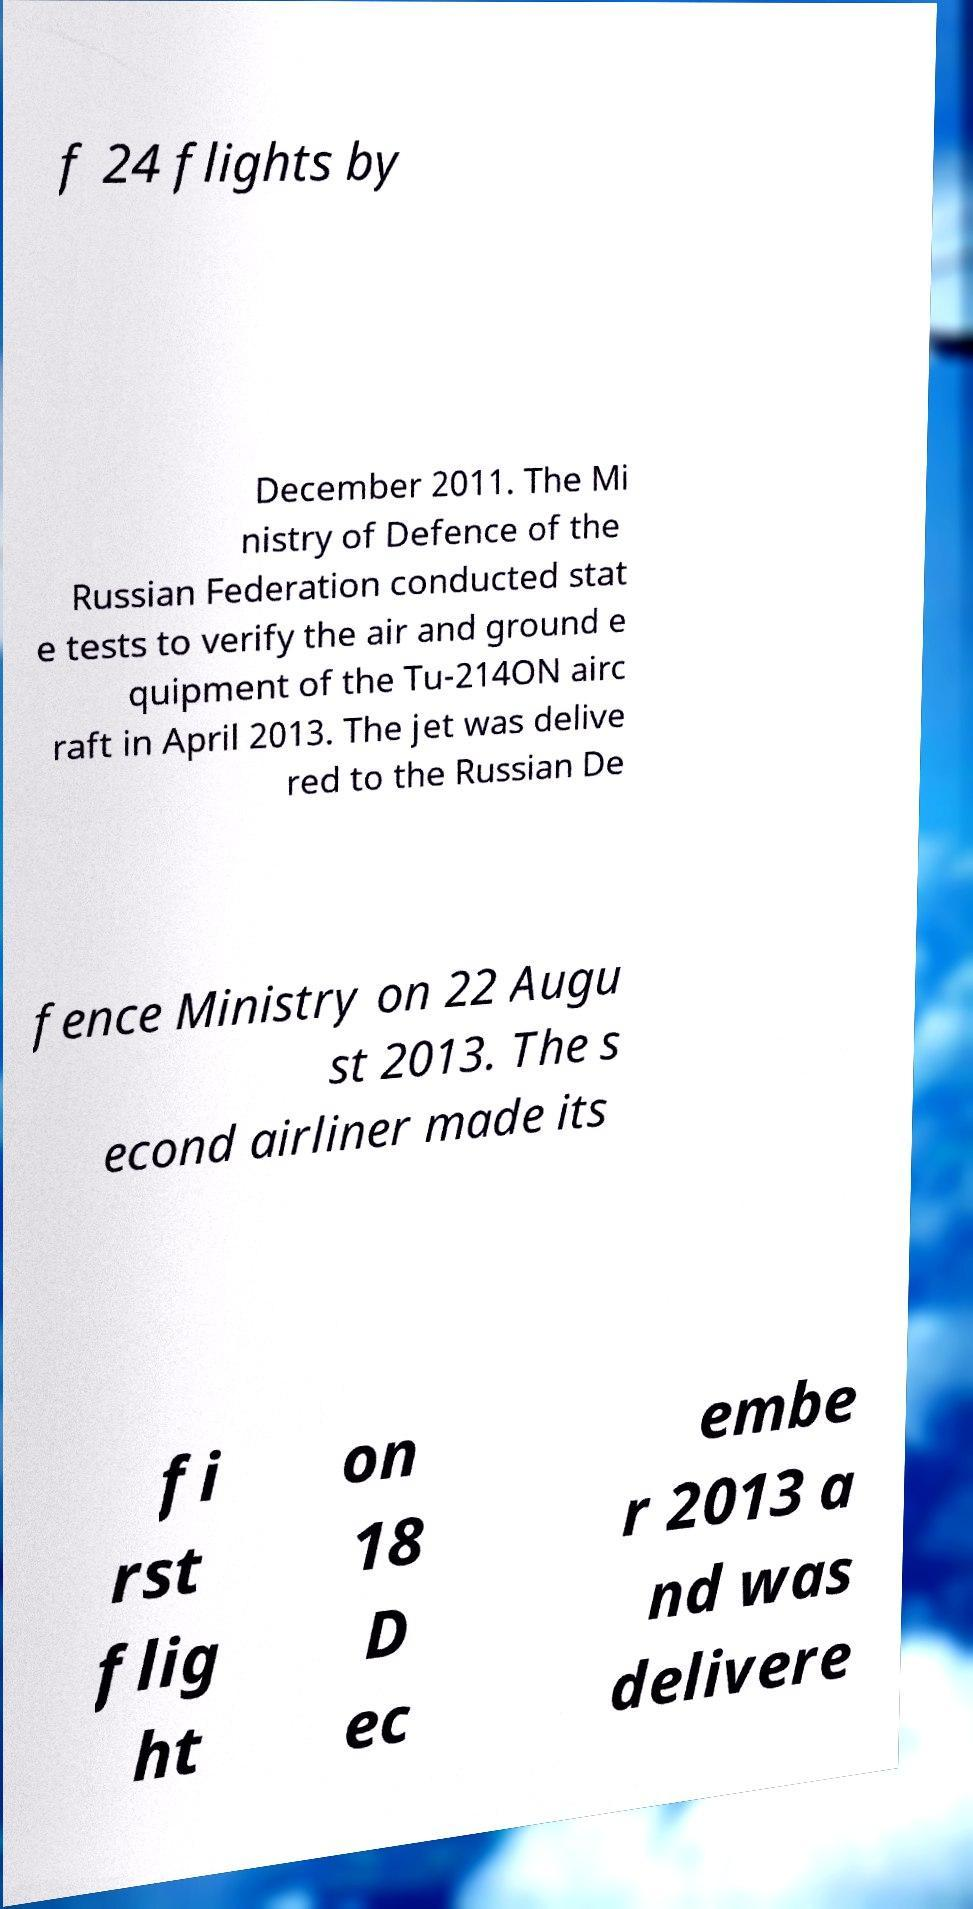For documentation purposes, I need the text within this image transcribed. Could you provide that? f 24 flights by December 2011. The Mi nistry of Defence of the Russian Federation conducted stat e tests to verify the air and ground e quipment of the Tu-214ON airc raft in April 2013. The jet was delive red to the Russian De fence Ministry on 22 Augu st 2013. The s econd airliner made its fi rst flig ht on 18 D ec embe r 2013 a nd was delivere 